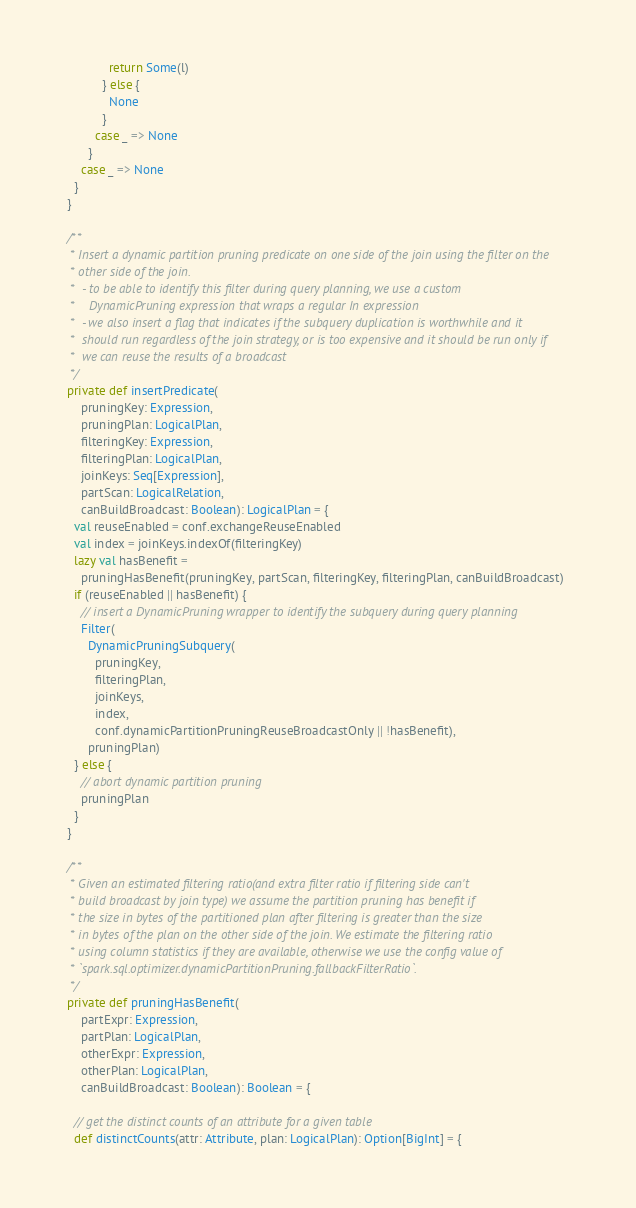<code> <loc_0><loc_0><loc_500><loc_500><_Scala_>              return Some(l)
            } else {
              None
            }
          case _ => None
        }
      case _ => None
    }
  }

  /**
   * Insert a dynamic partition pruning predicate on one side of the join using the filter on the
   * other side of the join.
   *  - to be able to identify this filter during query planning, we use a custom
   *    DynamicPruning expression that wraps a regular In expression
   *  - we also insert a flag that indicates if the subquery duplication is worthwhile and it
   *  should run regardless of the join strategy, or is too expensive and it should be run only if
   *  we can reuse the results of a broadcast
   */
  private def insertPredicate(
      pruningKey: Expression,
      pruningPlan: LogicalPlan,
      filteringKey: Expression,
      filteringPlan: LogicalPlan,
      joinKeys: Seq[Expression],
      partScan: LogicalRelation,
      canBuildBroadcast: Boolean): LogicalPlan = {
    val reuseEnabled = conf.exchangeReuseEnabled
    val index = joinKeys.indexOf(filteringKey)
    lazy val hasBenefit =
      pruningHasBenefit(pruningKey, partScan, filteringKey, filteringPlan, canBuildBroadcast)
    if (reuseEnabled || hasBenefit) {
      // insert a DynamicPruning wrapper to identify the subquery during query planning
      Filter(
        DynamicPruningSubquery(
          pruningKey,
          filteringPlan,
          joinKeys,
          index,
          conf.dynamicPartitionPruningReuseBroadcastOnly || !hasBenefit),
        pruningPlan)
    } else {
      // abort dynamic partition pruning
      pruningPlan
    }
  }

  /**
   * Given an estimated filtering ratio(and extra filter ratio if filtering side can't
   * build broadcast by join type) we assume the partition pruning has benefit if
   * the size in bytes of the partitioned plan after filtering is greater than the size
   * in bytes of the plan on the other side of the join. We estimate the filtering ratio
   * using column statistics if they are available, otherwise we use the config value of
   * `spark.sql.optimizer.dynamicPartitionPruning.fallbackFilterRatio`.
   */
  private def pruningHasBenefit(
      partExpr: Expression,
      partPlan: LogicalPlan,
      otherExpr: Expression,
      otherPlan: LogicalPlan,
      canBuildBroadcast: Boolean): Boolean = {

    // get the distinct counts of an attribute for a given table
    def distinctCounts(attr: Attribute, plan: LogicalPlan): Option[BigInt] = {</code> 